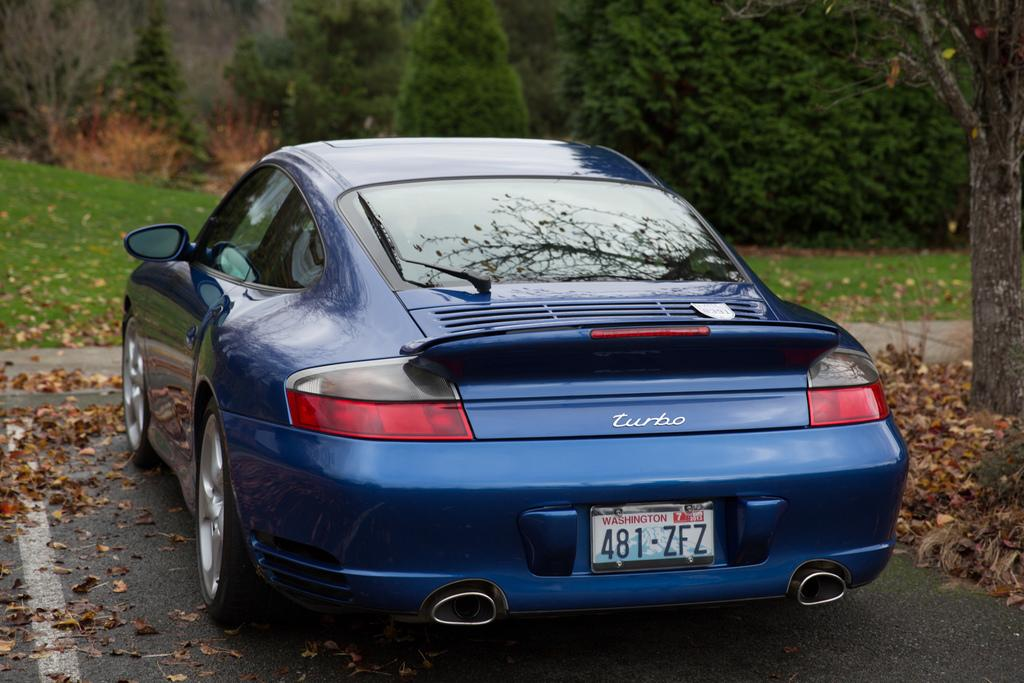Provide a one-sentence caption for the provided image. A blue car displays a plate from Washington that reads, "481-ZFZ.". 